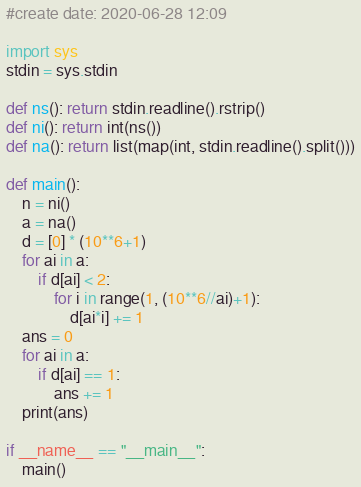Convert code to text. <code><loc_0><loc_0><loc_500><loc_500><_Python_>#create date: 2020-06-28 12:09

import sys
stdin = sys.stdin

def ns(): return stdin.readline().rstrip()
def ni(): return int(ns())
def na(): return list(map(int, stdin.readline().split()))

def main():
    n = ni()
    a = na()
    d = [0] * (10**6+1)
    for ai in a:
        if d[ai] < 2:
            for i in range(1, (10**6//ai)+1):
                d[ai*i] += 1
    ans = 0
    for ai in a:
        if d[ai] == 1:
            ans += 1
    print(ans)

if __name__ == "__main__":
    main()</code> 